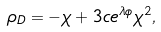Convert formula to latex. <formula><loc_0><loc_0><loc_500><loc_500>\rho _ { D } = - \chi + 3 c e ^ { \lambda \phi } \chi ^ { 2 } ,</formula> 